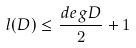<formula> <loc_0><loc_0><loc_500><loc_500>l ( D ) \leq \frac { d e g D } { 2 } + 1</formula> 